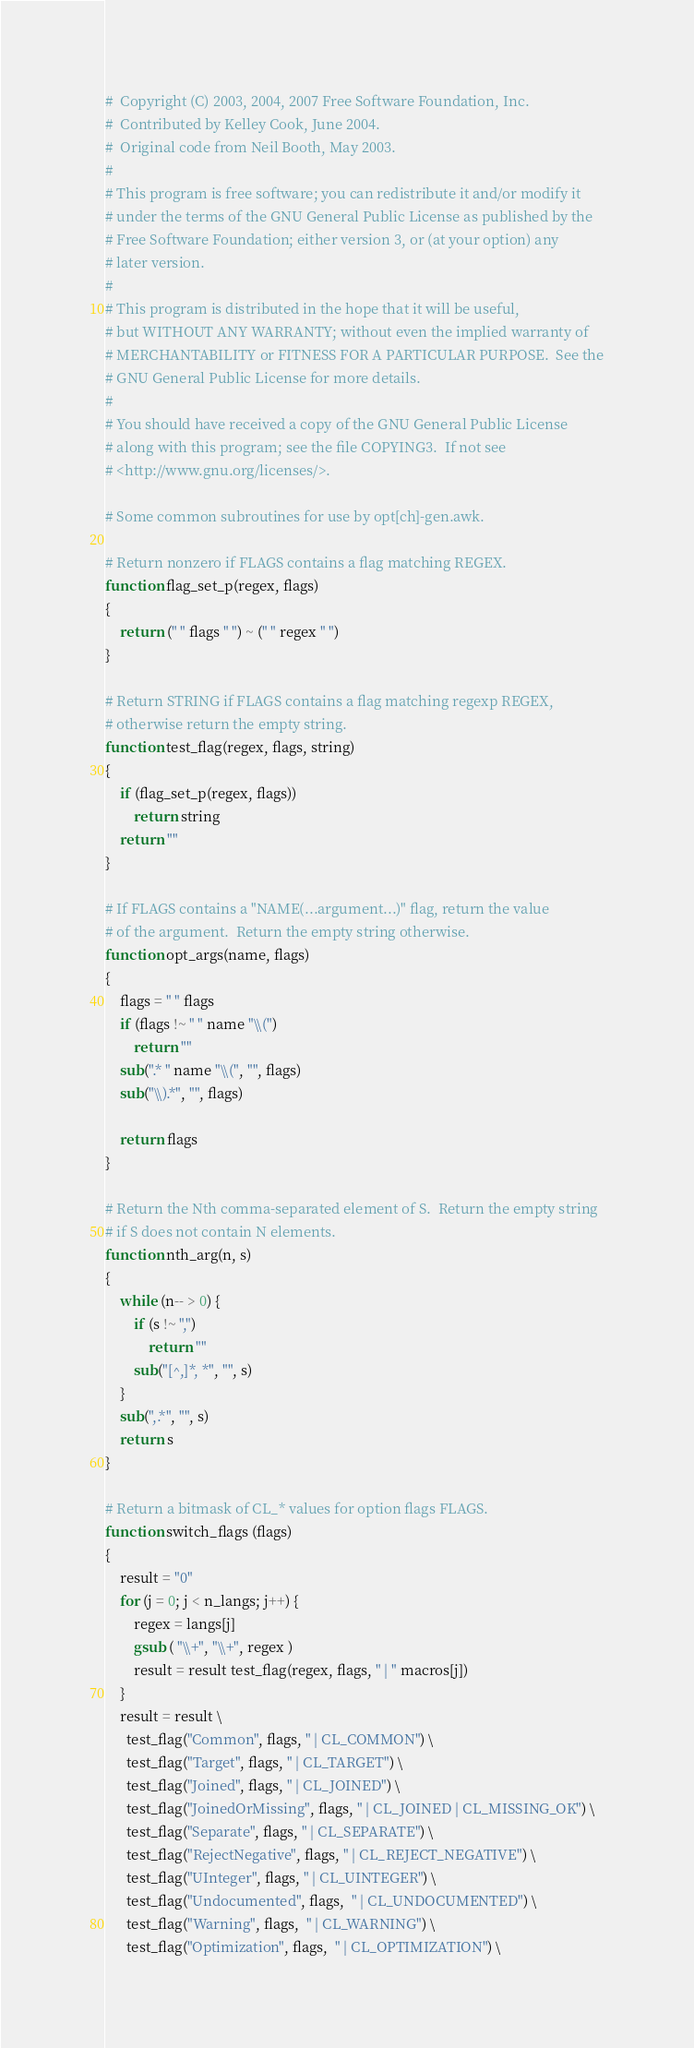<code> <loc_0><loc_0><loc_500><loc_500><_Awk_>#  Copyright (C) 2003, 2004, 2007 Free Software Foundation, Inc.
#  Contributed by Kelley Cook, June 2004.
#  Original code from Neil Booth, May 2003.
#
# This program is free software; you can redistribute it and/or modify it
# under the terms of the GNU General Public License as published by the
# Free Software Foundation; either version 3, or (at your option) any
# later version.
# 
# This program is distributed in the hope that it will be useful,
# but WITHOUT ANY WARRANTY; without even the implied warranty of
# MERCHANTABILITY or FITNESS FOR A PARTICULAR PURPOSE.  See the
# GNU General Public License for more details.
# 
# You should have received a copy of the GNU General Public License
# along with this program; see the file COPYING3.  If not see
# <http://www.gnu.org/licenses/>.

# Some common subroutines for use by opt[ch]-gen.awk.

# Return nonzero if FLAGS contains a flag matching REGEX.
function flag_set_p(regex, flags)
{
	return (" " flags " ") ~ (" " regex " ")
}

# Return STRING if FLAGS contains a flag matching regexp REGEX,
# otherwise return the empty string.
function test_flag(regex, flags, string)
{
	if (flag_set_p(regex, flags))
		return string
	return ""
}

# If FLAGS contains a "NAME(...argument...)" flag, return the value
# of the argument.  Return the empty string otherwise.
function opt_args(name, flags)
{
	flags = " " flags
	if (flags !~ " " name "\\(")
		return ""
	sub(".* " name "\\(", "", flags)
	sub("\\).*", "", flags)

	return flags
}

# Return the Nth comma-separated element of S.  Return the empty string
# if S does not contain N elements.
function nth_arg(n, s)
{
	while (n-- > 0) {
		if (s !~ ",")
			return ""
		sub("[^,]*, *", "", s)
	}
	sub(",.*", "", s)
	return s
}

# Return a bitmask of CL_* values for option flags FLAGS.
function switch_flags (flags)
{
	result = "0"
	for (j = 0; j < n_langs; j++) {
		regex = langs[j]
		gsub ( "\\+", "\\+", regex )
		result = result test_flag(regex, flags, " | " macros[j])
	}
	result = result \
	  test_flag("Common", flags, " | CL_COMMON") \
	  test_flag("Target", flags, " | CL_TARGET") \
	  test_flag("Joined", flags, " | CL_JOINED") \
	  test_flag("JoinedOrMissing", flags, " | CL_JOINED | CL_MISSING_OK") \
	  test_flag("Separate", flags, " | CL_SEPARATE") \
	  test_flag("RejectNegative", flags, " | CL_REJECT_NEGATIVE") \
	  test_flag("UInteger", flags, " | CL_UINTEGER") \
	  test_flag("Undocumented", flags,  " | CL_UNDOCUMENTED") \
	  test_flag("Warning", flags,  " | CL_WARNING") \
	  test_flag("Optimization", flags,  " | CL_OPTIMIZATION") \</code> 